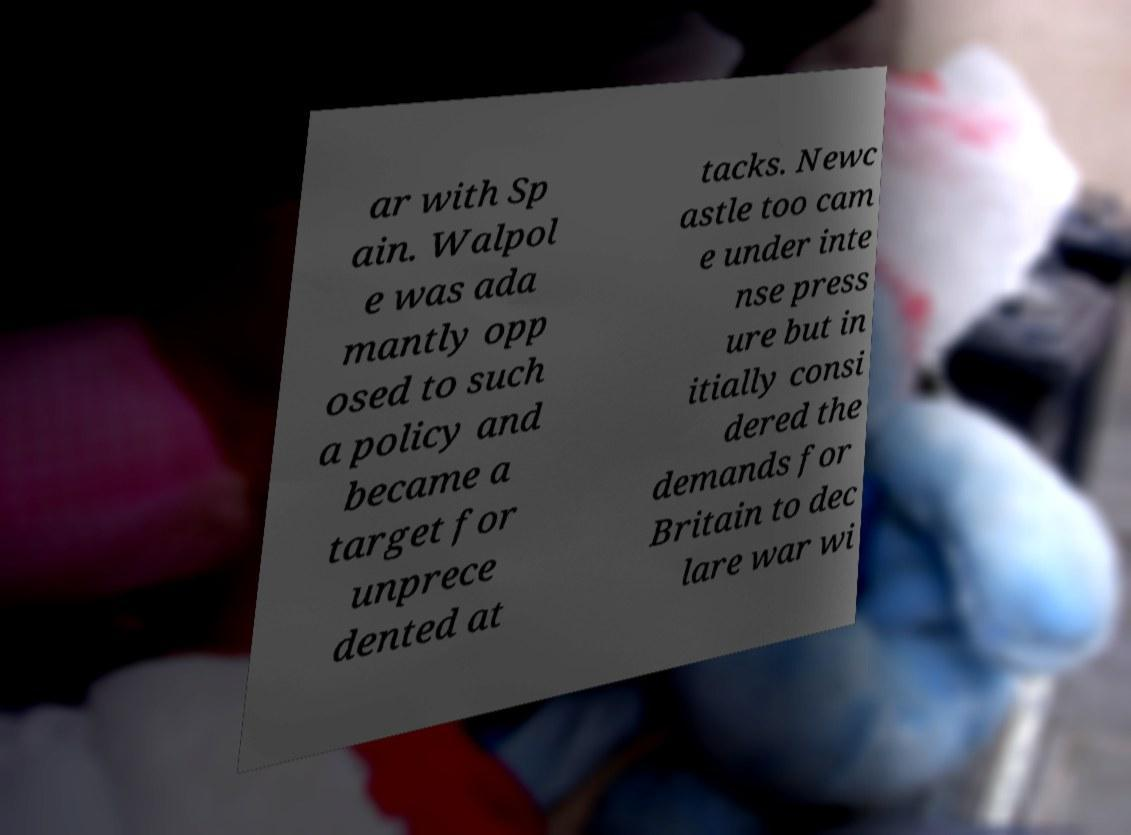Can you read and provide the text displayed in the image?This photo seems to have some interesting text. Can you extract and type it out for me? ar with Sp ain. Walpol e was ada mantly opp osed to such a policy and became a target for unprece dented at tacks. Newc astle too cam e under inte nse press ure but in itially consi dered the demands for Britain to dec lare war wi 